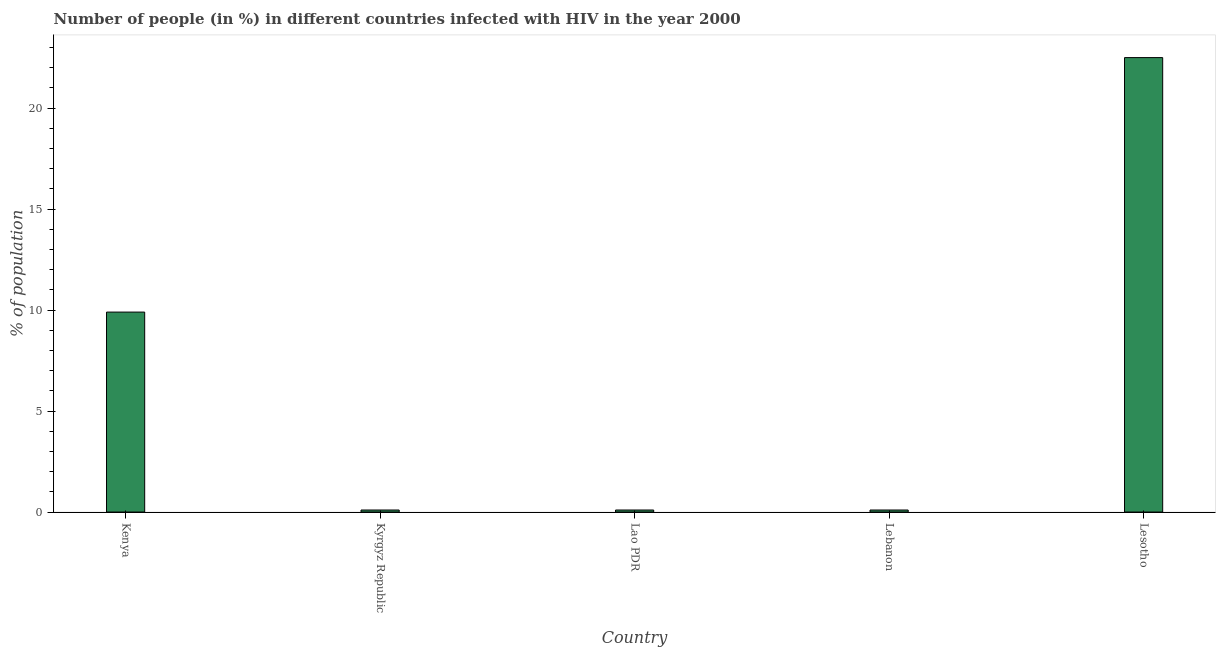Does the graph contain any zero values?
Keep it short and to the point. No. What is the title of the graph?
Make the answer very short. Number of people (in %) in different countries infected with HIV in the year 2000. What is the label or title of the X-axis?
Offer a terse response. Country. What is the label or title of the Y-axis?
Offer a terse response. % of population. In which country was the number of people infected with hiv maximum?
Make the answer very short. Lesotho. In which country was the number of people infected with hiv minimum?
Your answer should be very brief. Kyrgyz Republic. What is the sum of the number of people infected with hiv?
Provide a succinct answer. 32.7. What is the average number of people infected with hiv per country?
Make the answer very short. 6.54. What is the median number of people infected with hiv?
Provide a short and direct response. 0.1. Is the difference between the number of people infected with hiv in Kenya and Lao PDR greater than the difference between any two countries?
Provide a short and direct response. No. What is the difference between the highest and the second highest number of people infected with hiv?
Your answer should be very brief. 12.6. What is the difference between the highest and the lowest number of people infected with hiv?
Offer a very short reply. 22.4. How many bars are there?
Offer a very short reply. 5. Are all the bars in the graph horizontal?
Your answer should be very brief. No. What is the % of population of Kenya?
Make the answer very short. 9.9. What is the % of population of Kyrgyz Republic?
Make the answer very short. 0.1. What is the % of population of Lao PDR?
Make the answer very short. 0.1. What is the difference between the % of population in Kenya and Kyrgyz Republic?
Your response must be concise. 9.8. What is the difference between the % of population in Kyrgyz Republic and Lebanon?
Offer a very short reply. 0. What is the difference between the % of population in Kyrgyz Republic and Lesotho?
Give a very brief answer. -22.4. What is the difference between the % of population in Lao PDR and Lesotho?
Keep it short and to the point. -22.4. What is the difference between the % of population in Lebanon and Lesotho?
Your answer should be very brief. -22.4. What is the ratio of the % of population in Kenya to that in Kyrgyz Republic?
Your answer should be very brief. 99. What is the ratio of the % of population in Kenya to that in Lao PDR?
Keep it short and to the point. 99. What is the ratio of the % of population in Kenya to that in Lesotho?
Ensure brevity in your answer.  0.44. What is the ratio of the % of population in Kyrgyz Republic to that in Lao PDR?
Provide a short and direct response. 1. What is the ratio of the % of population in Kyrgyz Republic to that in Lesotho?
Offer a terse response. 0. What is the ratio of the % of population in Lao PDR to that in Lebanon?
Your answer should be compact. 1. What is the ratio of the % of population in Lao PDR to that in Lesotho?
Your answer should be compact. 0. What is the ratio of the % of population in Lebanon to that in Lesotho?
Offer a very short reply. 0. 